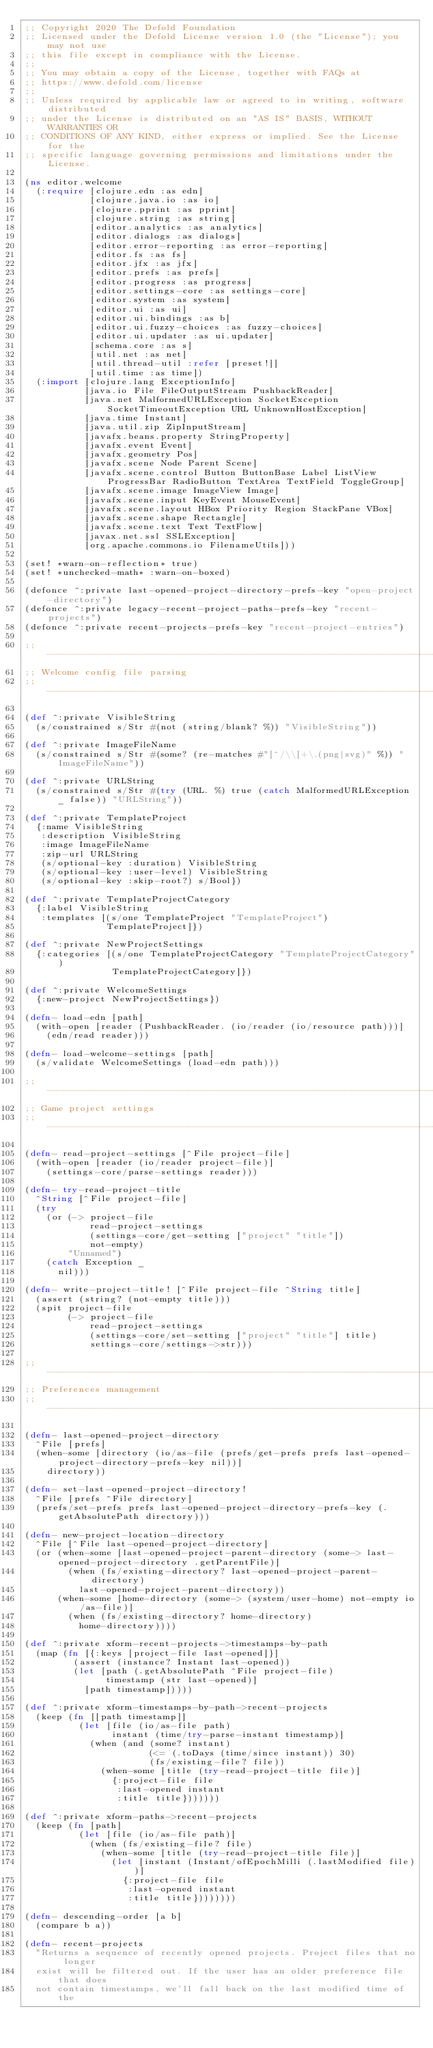Convert code to text. <code><loc_0><loc_0><loc_500><loc_500><_Clojure_>;; Copyright 2020 The Defold Foundation
;; Licensed under the Defold License version 1.0 (the "License"); you may not use
;; this file except in compliance with the License.
;; 
;; You may obtain a copy of the License, together with FAQs at
;; https://www.defold.com/license
;; 
;; Unless required by applicable law or agreed to in writing, software distributed
;; under the License is distributed on an "AS IS" BASIS, WITHOUT WARRANTIES OR
;; CONDITIONS OF ANY KIND, either express or implied. See the License for the
;; specific language governing permissions and limitations under the License.

(ns editor.welcome
  (:require [clojure.edn :as edn]
            [clojure.java.io :as io]
            [clojure.pprint :as pprint]
            [clojure.string :as string]
            [editor.analytics :as analytics]
            [editor.dialogs :as dialogs]
            [editor.error-reporting :as error-reporting]
            [editor.fs :as fs]
            [editor.jfx :as jfx]
            [editor.prefs :as prefs]
            [editor.progress :as progress]
            [editor.settings-core :as settings-core]
            [editor.system :as system]
            [editor.ui :as ui]
            [editor.ui.bindings :as b]
            [editor.ui.fuzzy-choices :as fuzzy-choices]
            [editor.ui.updater :as ui.updater]
            [schema.core :as s]
            [util.net :as net]
            [util.thread-util :refer [preset!]]
            [util.time :as time])
  (:import [clojure.lang ExceptionInfo]
           [java.io File FileOutputStream PushbackReader]
           [java.net MalformedURLException SocketException SocketTimeoutException URL UnknownHostException]
           [java.time Instant]
           [java.util.zip ZipInputStream]
           [javafx.beans.property StringProperty]
           [javafx.event Event]
           [javafx.geometry Pos]
           [javafx.scene Node Parent Scene]
           [javafx.scene.control Button ButtonBase Label ListView ProgressBar RadioButton TextArea TextField ToggleGroup]
           [javafx.scene.image ImageView Image]
           [javafx.scene.input KeyEvent MouseEvent]
           [javafx.scene.layout HBox Priority Region StackPane VBox]
           [javafx.scene.shape Rectangle]
           [javafx.scene.text Text TextFlow]
           [javax.net.ssl SSLException]
           [org.apache.commons.io FilenameUtils]))

(set! *warn-on-reflection* true)
(set! *unchecked-math* :warn-on-boxed)

(defonce ^:private last-opened-project-directory-prefs-key "open-project-directory")
(defonce ^:private legacy-recent-project-paths-prefs-key "recent-projects")
(defonce ^:private recent-projects-prefs-key "recent-project-entries")

;; -----------------------------------------------------------------------------
;; Welcome config file parsing
;; -----------------------------------------------------------------------------

(def ^:private VisibleString
  (s/constrained s/Str #(not (string/blank? %)) "VisibleString"))

(def ^:private ImageFileName
  (s/constrained s/Str #(some? (re-matches #"[^/\\]+\.(png|svg)" %)) "ImageFileName"))

(def ^:private URLString
  (s/constrained s/Str #(try (URL. %) true (catch MalformedURLException _ false)) "URLString"))

(def ^:private TemplateProject
  {:name VisibleString
   :description VisibleString
   :image ImageFileName
   :zip-url URLString
   (s/optional-key :duration) VisibleString
   (s/optional-key :user-level) VisibleString
   (s/optional-key :skip-root?) s/Bool})

(def ^:private TemplateProjectCategory
  {:label VisibleString
   :templates [(s/one TemplateProject "TemplateProject")
               TemplateProject]})

(def ^:private NewProjectSettings
  {:categories [(s/one TemplateProjectCategory "TemplateProjectCategory")
                TemplateProjectCategory]})

(def ^:private WelcomeSettings
  {:new-project NewProjectSettings})

(defn- load-edn [path]
  (with-open [reader (PushbackReader. (io/reader (io/resource path)))]
    (edn/read reader)))

(defn- load-welcome-settings [path]
  (s/validate WelcomeSettings (load-edn path)))

;; -----------------------------------------------------------------------------
;; Game project settings
;; -----------------------------------------------------------------------------

(defn- read-project-settings [^File project-file]
  (with-open [reader (io/reader project-file)]
    (settings-core/parse-settings reader)))

(defn- try-read-project-title
  ^String [^File project-file]
  (try
    (or (-> project-file
            read-project-settings
            (settings-core/get-setting ["project" "title"])
            not-empty)
        "Unnamed")
    (catch Exception _
      nil)))

(defn- write-project-title! [^File project-file ^String title]
  (assert (string? (not-empty title)))
  (spit project-file
        (-> project-file
            read-project-settings
            (settings-core/set-setting ["project" "title"] title)
            settings-core/settings->str)))

;; -----------------------------------------------------------------------------
;; Preferences management
;; -----------------------------------------------------------------------------

(defn- last-opened-project-directory
  ^File [prefs]
  (when-some [directory (io/as-file (prefs/get-prefs prefs last-opened-project-directory-prefs-key nil))]
    directory))

(defn- set-last-opened-project-directory!
  ^File [prefs ^File directory]
  (prefs/set-prefs prefs last-opened-project-directory-prefs-key (.getAbsolutePath directory)))

(defn- new-project-location-directory
  ^File [^File last-opened-project-directory]
  (or (when-some [last-opened-project-parent-directory (some-> last-opened-project-directory .getParentFile)]
        (when (fs/existing-directory? last-opened-project-parent-directory)
          last-opened-project-parent-directory))
      (when-some [home-directory (some-> (system/user-home) not-empty io/as-file)]
        (when (fs/existing-directory? home-directory)
          home-directory))))

(def ^:private xform-recent-projects->timestamps-by-path
  (map (fn [{:keys [project-file last-opened]}]
         (assert (instance? Instant last-opened))
         (let [path (.getAbsolutePath ^File project-file)
               timestamp (str last-opened)]
           [path timestamp]))))

(def ^:private xform-timestamps-by-path->recent-projects
  (keep (fn [[path timestamp]]
          (let [file (io/as-file path)
                instant (time/try-parse-instant timestamp)]
            (when (and (some? instant)
                       (<= (.toDays (time/since instant)) 30)
                       (fs/existing-file? file))
              (when-some [title (try-read-project-title file)]
                {:project-file file
                 :last-opened instant
                 :title title}))))))

(def ^:private xform-paths->recent-projects
  (keep (fn [path]
          (let [file (io/as-file path)]
            (when (fs/existing-file? file)
              (when-some [title (try-read-project-title file)]
                (let [instant (Instant/ofEpochMilli (.lastModified file))]
                  {:project-file file
                   :last-opened instant
                   :title title})))))))

(defn- descending-order [a b]
  (compare b a))

(defn- recent-projects
  "Returns a sequence of recently opened projects. Project files that no longer
  exist will be filtered out. If the user has an older preference file that does
  not contain timestamps, we'll fall back on the last modified time of the</code> 